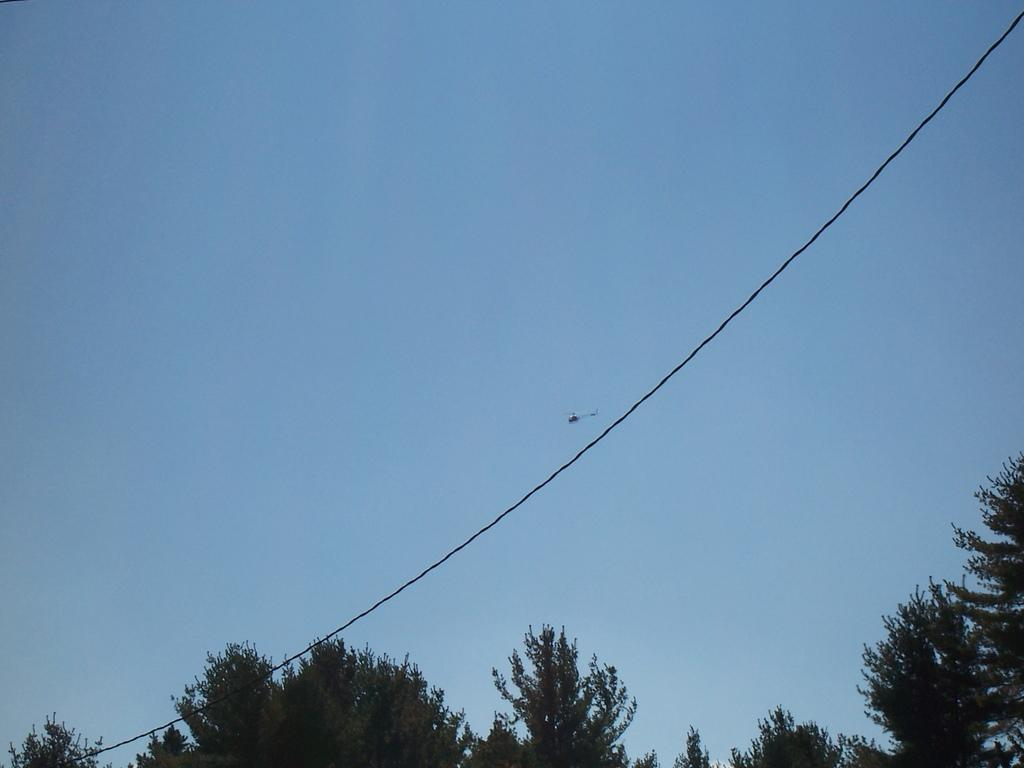What color is the sky in the image? The sky is blue in the image. What type of vegetation can be seen in the image? There are green trees visible in the image. What type of jewel can be seen sparkling in the mist in the image? There is no jewel or mist present in the image; it only features a blue sky and green trees. 